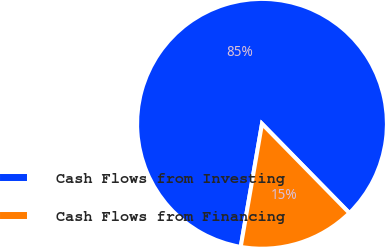Convert chart. <chart><loc_0><loc_0><loc_500><loc_500><pie_chart><fcel>Cash Flows from Investing<fcel>Cash Flows from Financing<nl><fcel>84.94%<fcel>15.06%<nl></chart> 